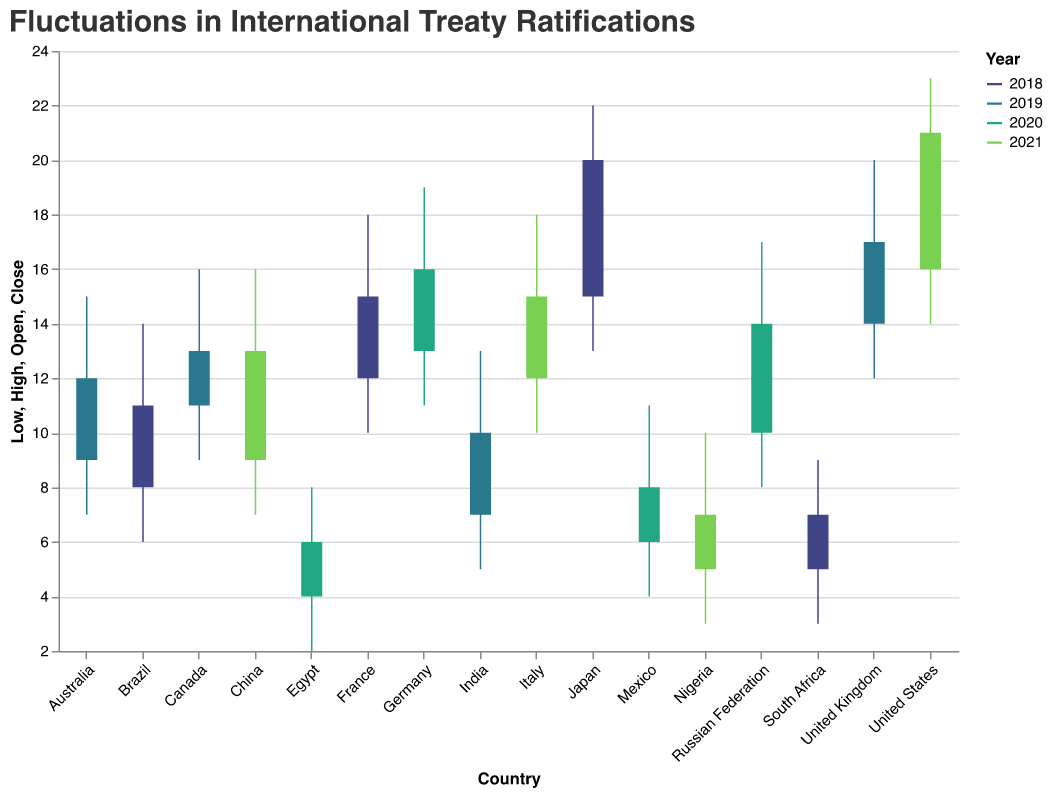Which country had the highest number of international treaty ratifications in 2018? Look for the highest 'High' value among the 2018 data points and identify the corresponding country. Japan has the highest 'High' value of 22 in 2018.
Answer: Japan What is the general trend in treaty ratifications from 2018 to 2021 for Japan? Compare the 'Open' and 'Close' values for Japan in both 2018 and 2021. In 2018, the 'Open' is 15 and the 'Close' is 20. Japan is not listed for 2021, implying no direct comparison can be made. Thus, the treaty ratifications only decreased from the 'High' value of 22 to the 'Close' value of 20 in 2018.
Answer: Decrease Which year saw the highest 'High' value for international treaty ratifications among all the countries in the dataset? Look for the highest 'High' value overall in the dataset. The 'High' value of 23 for the United States in 2021 is the highest.
Answer: 2021 On average, did the number of treaty ratifications increase or decrease for all countries listed in 2019 compared to their 'Open' values in that year? Calculate the average of the 'Open' values and 'Close' values for all countries in 2019 and compare them. The 'Open' values sum to (14 + 7 + 11 + 9) = 41, average is 41/4 = 10.25; 'Close' values sum to (17 + 10 + 13 + 12) = 52, average is 52/4 = 13. The average number of treaty ratifications increased.
Answer: Increase For which country and year is the difference between the 'High' and 'Low' values the largest? Calculate the difference between 'High' and 'Low' for each country and year. The largest difference is (23 - 14) = 9 for the United States in 2021.
Answer: United States, 2021 Which country had the most significant drop in treaty ratifications from 'High' to 'Close' within a single year? Calculate the difference between 'High' and 'Close' for each country and identify the largest drop. The most significant drop is for South Africa in 2018 with a drop of (9 - 7) = 2.
Answer: South Africa, 2018 How many countries had their 'Close' values higher than their 'Open' values in 2020? Compare 'Close' and 'Open' values for all countries in 2020. Germany (16 > 13) and the Russian Federation (14 > 10) had their 'Close' values higher than their 'Open' values. Two countries had an increase.
Answer: 2 Compare the ranges (High-Low) for Brazil and India. Which country has a larger range in treaty ratifications and what are the values? Calculate the range for both Brazil and India. Brazil in 2018 has a range of (14 - 6) = 8, and India in 2019 has a range of (13 - 5) = 8. Both have the same range.
Answer: Both have the same range, 8 Which countries had the same 'Close' value in 2020 and 2021? Compare the 'Close' values of all countries listed for 2020 and 2021. Canada in 2019 and China in 2021 both have a 'Close' value of 13.
Answer: Canada and China In 2019, which country had the smallest increase in treaty ratifications from 'Open' to 'Close'? Compare the 'Open' and 'Close' values for all countries in 2019 and find the smallest positive difference. India had an increase of (10 - 7) = 3, which is the smallest.
Answer: India 